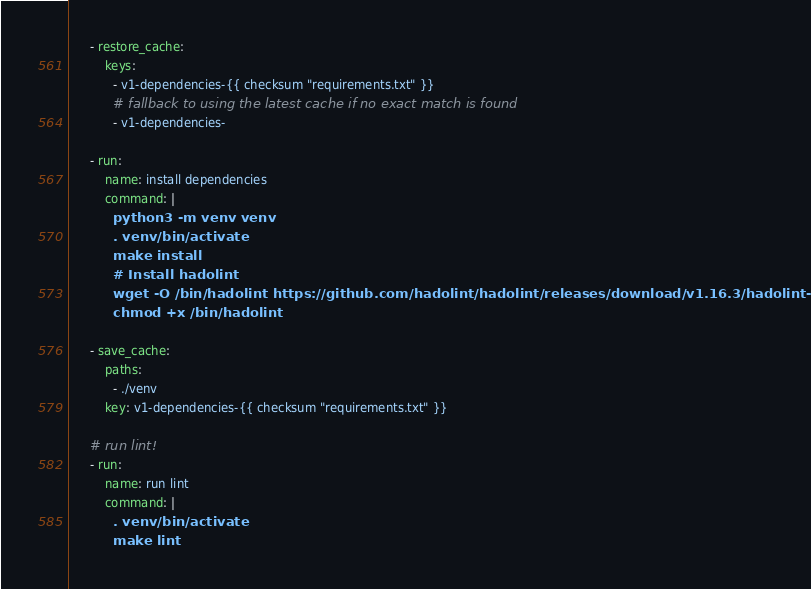Convert code to text. <code><loc_0><loc_0><loc_500><loc_500><_YAML_>      - restore_cache:
          keys:
            - v1-dependencies-{{ checksum "requirements.txt" }}
            # fallback to using the latest cache if no exact match is found
            - v1-dependencies-

      - run:
          name: install dependencies
          command: |
            python3 -m venv venv
            . venv/bin/activate
            make install
            # Install hadolint
            wget -O /bin/hadolint https://github.com/hadolint/hadolint/releases/download/v1.16.3/hadolint-Linux-x86_64 &&\
            chmod +x /bin/hadolint

      - save_cache:
          paths:
            - ./venv
          key: v1-dependencies-{{ checksum "requirements.txt" }}

      # run lint!
      - run:
          name: run lint
          command: |
            . venv/bin/activate
            make lint</code> 